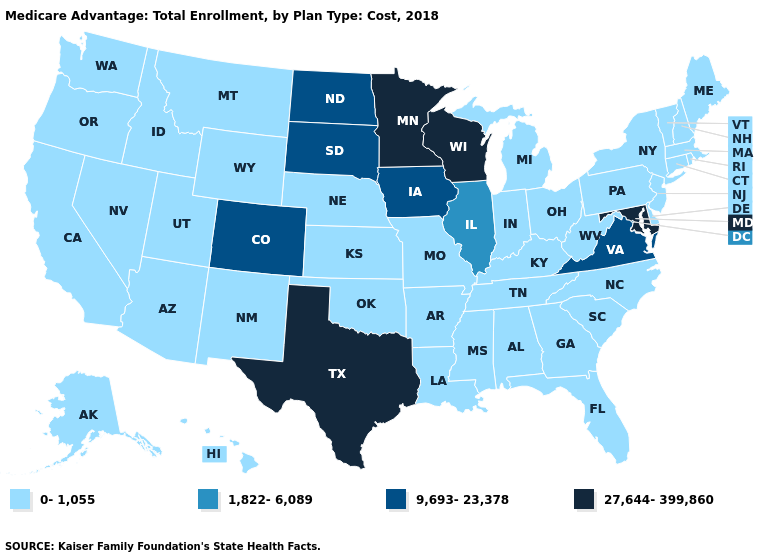Does Virginia have the lowest value in the South?
Write a very short answer. No. What is the lowest value in the USA?
Answer briefly. 0-1,055. Does Texas have the lowest value in the South?
Write a very short answer. No. How many symbols are there in the legend?
Keep it brief. 4. What is the lowest value in the USA?
Keep it brief. 0-1,055. What is the highest value in the USA?
Be succinct. 27,644-399,860. Name the states that have a value in the range 1,822-6,089?
Quick response, please. Illinois. Which states hav the highest value in the South?
Concise answer only. Maryland, Texas. What is the lowest value in the USA?
Short answer required. 0-1,055. Name the states that have a value in the range 1,822-6,089?
Answer briefly. Illinois. What is the value of Indiana?
Short answer required. 0-1,055. Does Colorado have the lowest value in the USA?
Give a very brief answer. No. Is the legend a continuous bar?
Give a very brief answer. No. What is the lowest value in the USA?
Give a very brief answer. 0-1,055. Name the states that have a value in the range 1,822-6,089?
Give a very brief answer. Illinois. 